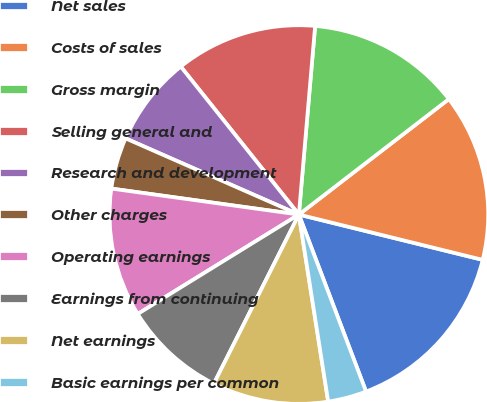<chart> <loc_0><loc_0><loc_500><loc_500><pie_chart><fcel>Net sales<fcel>Costs of sales<fcel>Gross margin<fcel>Selling general and<fcel>Research and development<fcel>Other charges<fcel>Operating earnings<fcel>Earnings from continuing<fcel>Net earnings<fcel>Basic earnings per common<nl><fcel>15.38%<fcel>14.29%<fcel>13.19%<fcel>12.09%<fcel>7.69%<fcel>4.4%<fcel>10.99%<fcel>8.79%<fcel>9.89%<fcel>3.3%<nl></chart> 